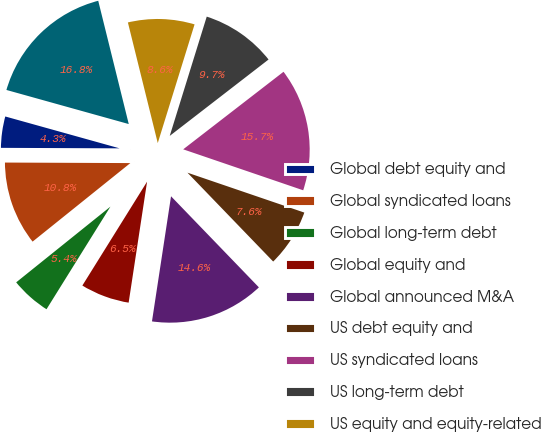<chart> <loc_0><loc_0><loc_500><loc_500><pie_chart><fcel>Global debt equity and<fcel>Global syndicated loans<fcel>Global long-term debt<fcel>Global equity and<fcel>Global announced M&A<fcel>US debt equity and<fcel>US syndicated loans<fcel>US long-term debt<fcel>US equity and equity-related<fcel>US announced M&A<nl><fcel>4.26%<fcel>10.84%<fcel>5.36%<fcel>6.46%<fcel>14.62%<fcel>7.55%<fcel>15.71%<fcel>9.74%<fcel>8.65%<fcel>16.81%<nl></chart> 